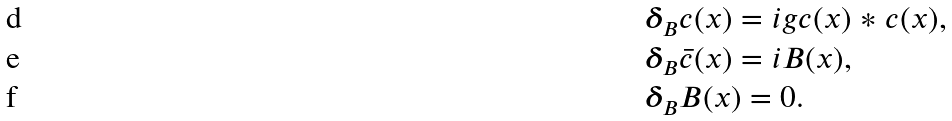<formula> <loc_0><loc_0><loc_500><loc_500>& \boldsymbol \delta _ { \text {$ B$} } c ( x ) = i g c ( x ) \ast c ( x ) , \\ & \boldsymbol \delta _ { \text {$ B$} } { \bar { c } } ( x ) = i B ( x ) , \\ & \boldsymbol \delta _ { \text {$ B$} } B ( x ) = 0 .</formula> 